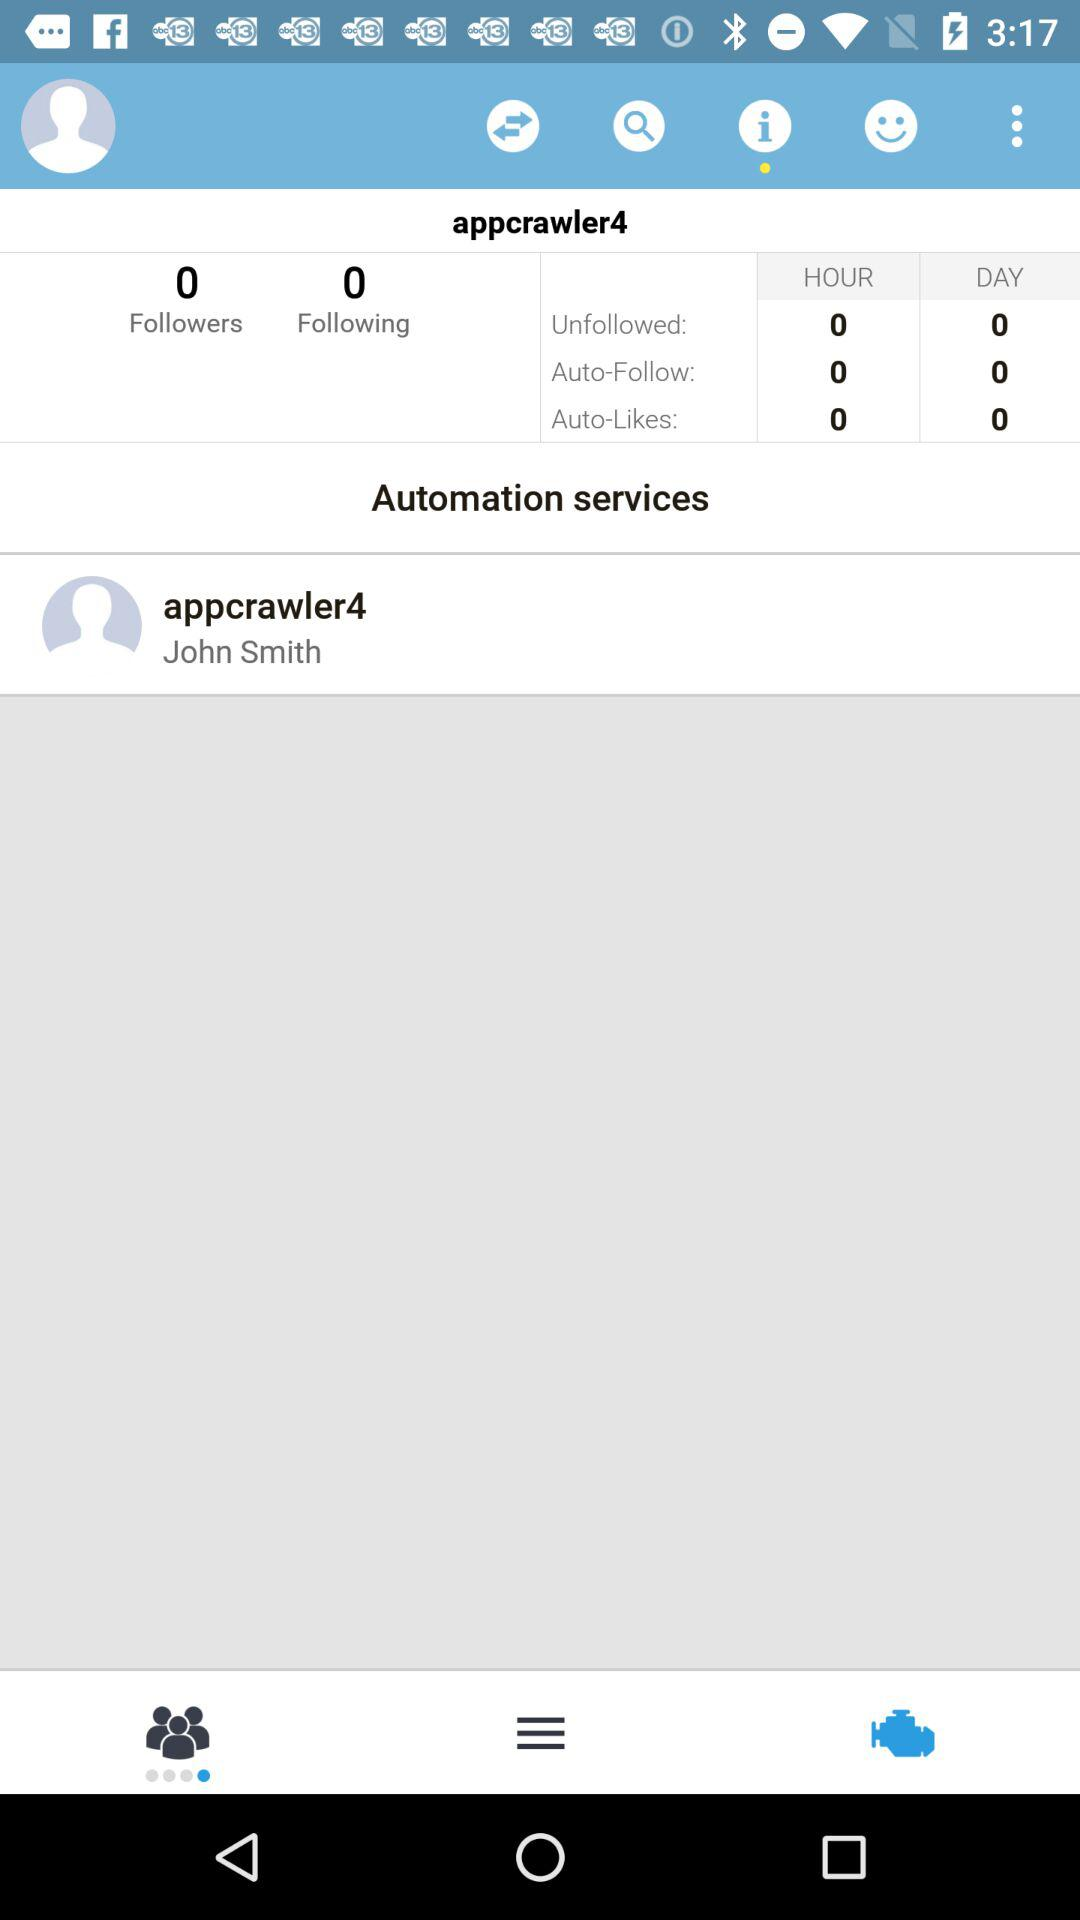What is the count of followers? The count of followers is 0. 